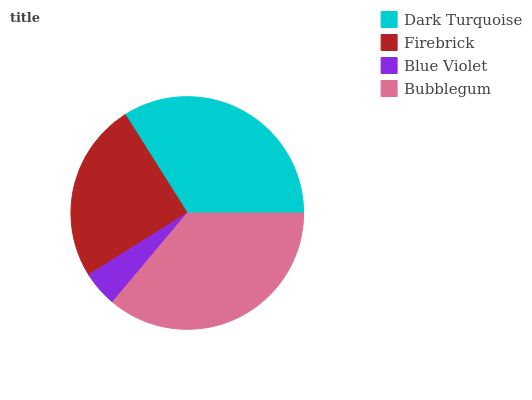Is Blue Violet the minimum?
Answer yes or no. Yes. Is Bubblegum the maximum?
Answer yes or no. Yes. Is Firebrick the minimum?
Answer yes or no. No. Is Firebrick the maximum?
Answer yes or no. No. Is Dark Turquoise greater than Firebrick?
Answer yes or no. Yes. Is Firebrick less than Dark Turquoise?
Answer yes or no. Yes. Is Firebrick greater than Dark Turquoise?
Answer yes or no. No. Is Dark Turquoise less than Firebrick?
Answer yes or no. No. Is Dark Turquoise the high median?
Answer yes or no. Yes. Is Firebrick the low median?
Answer yes or no. Yes. Is Bubblegum the high median?
Answer yes or no. No. Is Dark Turquoise the low median?
Answer yes or no. No. 